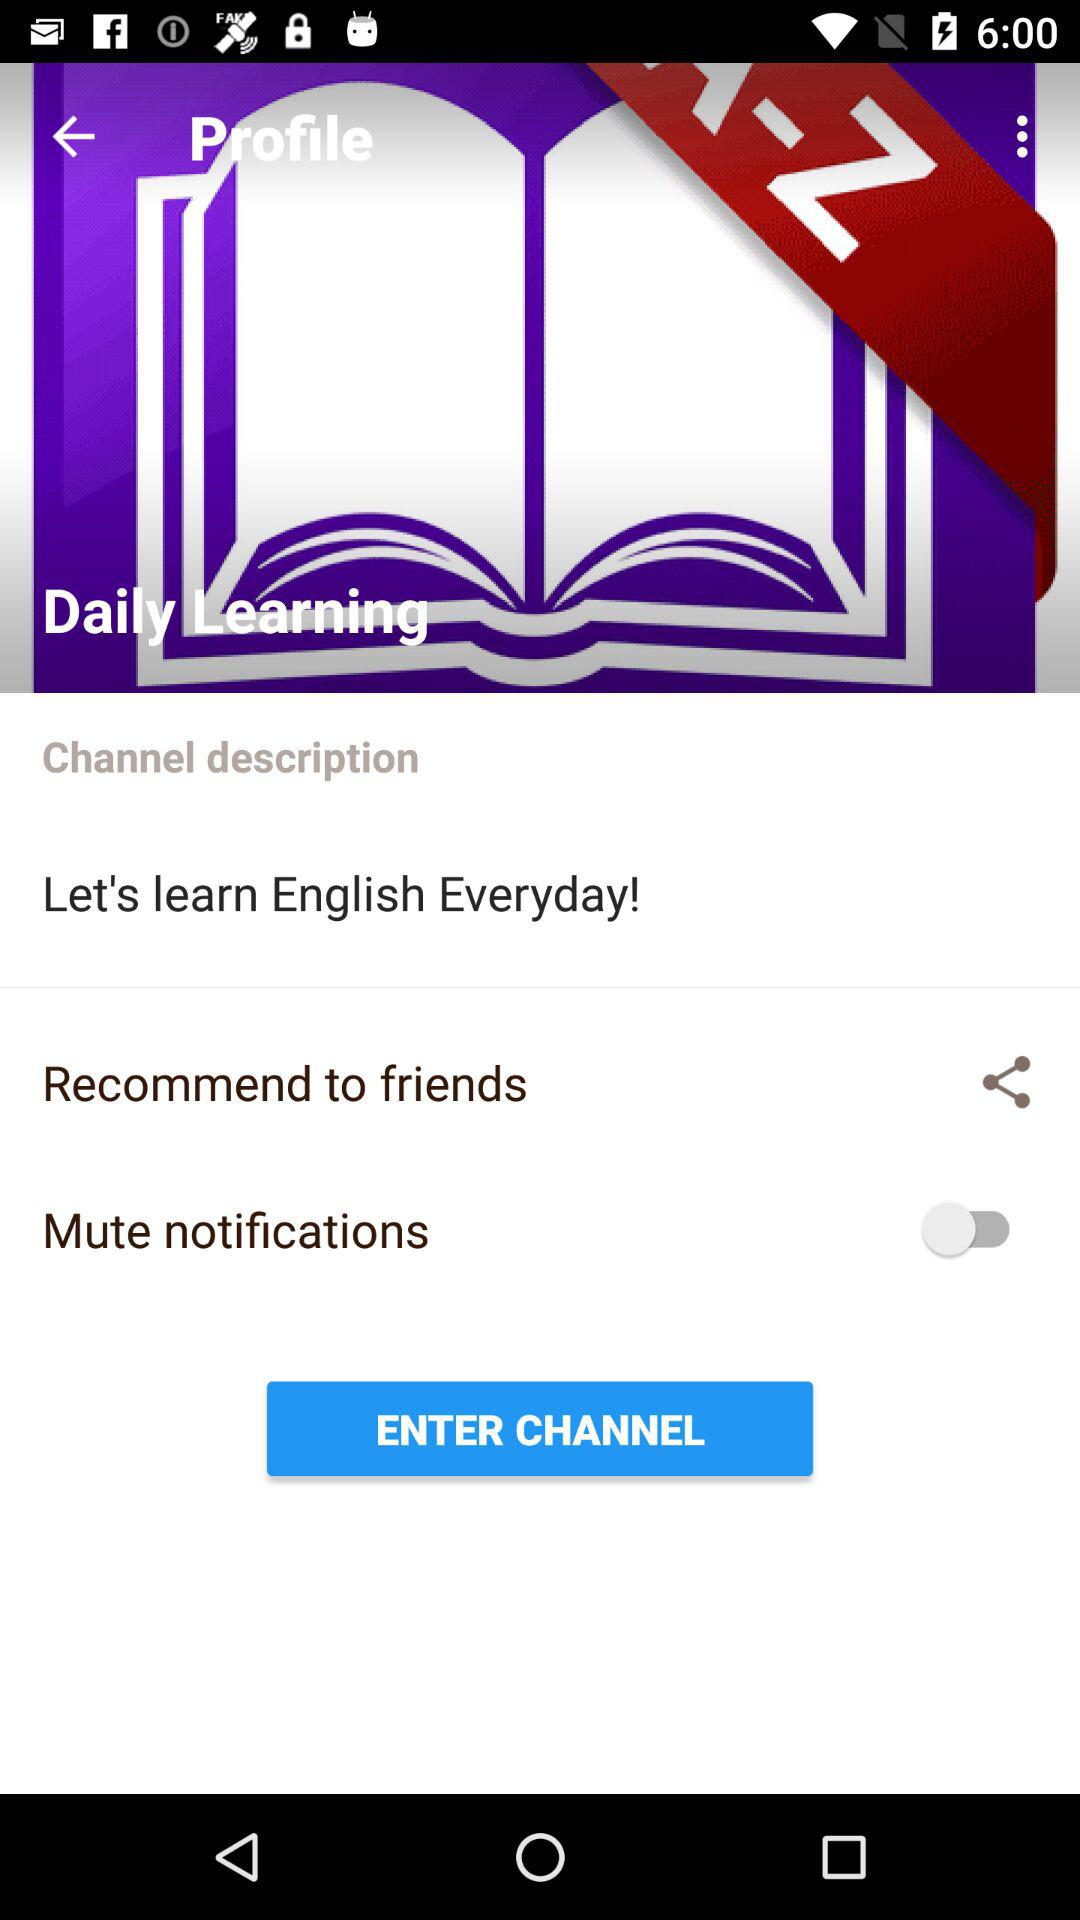What is the current status of the "Mute notifications" setting? The status is off. 